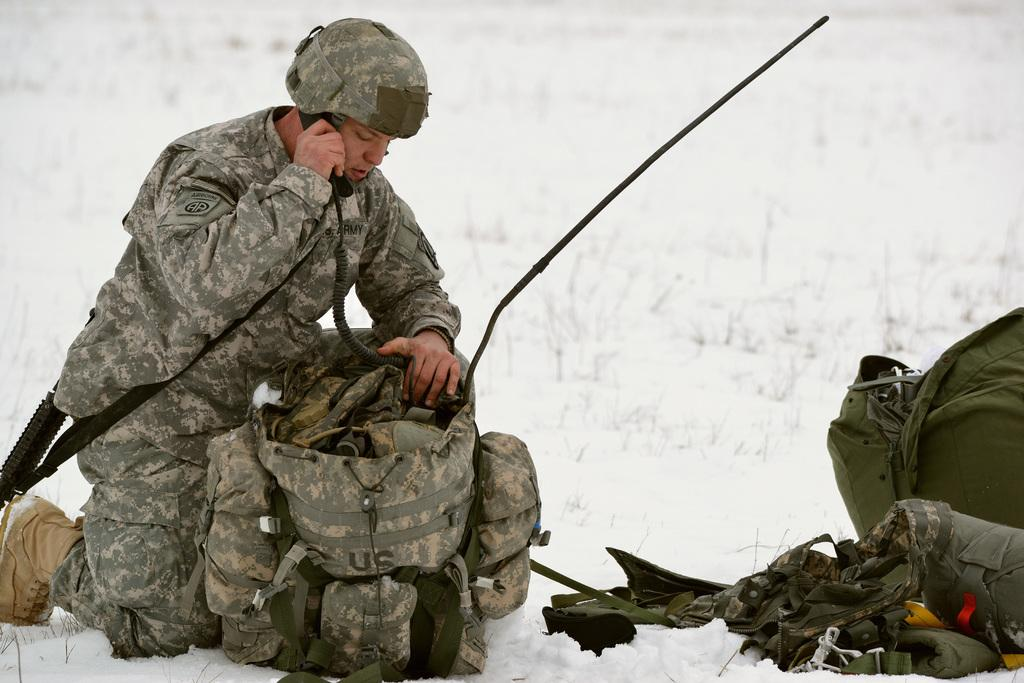Who or what is present in the image? There is a person in the image. What is the person carrying or holding in the image? There are bags in the image. Can you describe any other objects in the image? There are other objects in the image, but their specific details are not mentioned in the provided facts. What can be seen in the background of the image? There is snow and grass in the background of the image. How many babies are crawling on the person's tail in the image? There is no tail or babies present in the image. 